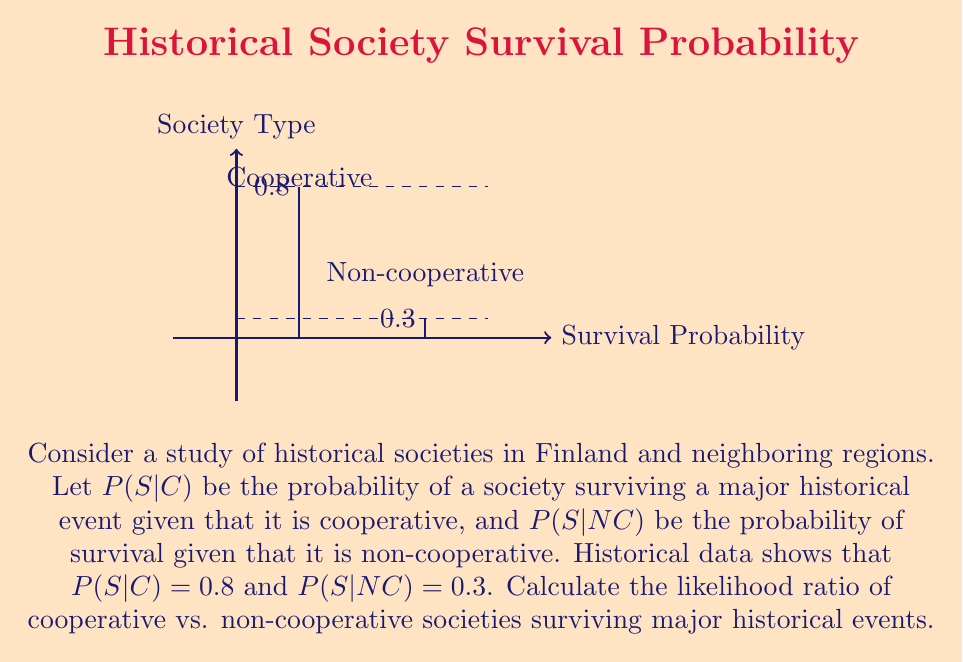What is the answer to this math problem? To solve this problem, we need to understand the concept of likelihood ratio and how to calculate it using the given probabilities.

1. The likelihood ratio (LR) is defined as the ratio of the probability of an event under one hypothesis to the probability of the same event under an alternative hypothesis.

2. In this case, we want to compare the likelihood of survival for cooperative societies vs. non-cooperative societies.

3. The formula for the likelihood ratio is:

   $$LR = \frac{P(S|C)}{P(S|NC)}$$

   where $P(S|C)$ is the probability of survival given a cooperative society, and $P(S|NC)$ is the probability of survival given a non-cooperative society.

4. We are given:
   $P(S|C) = 0.8$
   $P(S|NC) = 0.3$

5. Substituting these values into the formula:

   $$LR = \frac{0.8}{0.3}$$

6. Calculating the ratio:

   $$LR = \frac{8}{3} \approx 2.67$$

This means that cooperative societies are about 2.67 times more likely to survive major historical events compared to non-cooperative societies, based on the given data.
Answer: $\frac{8}{3}$ or approximately 2.67 